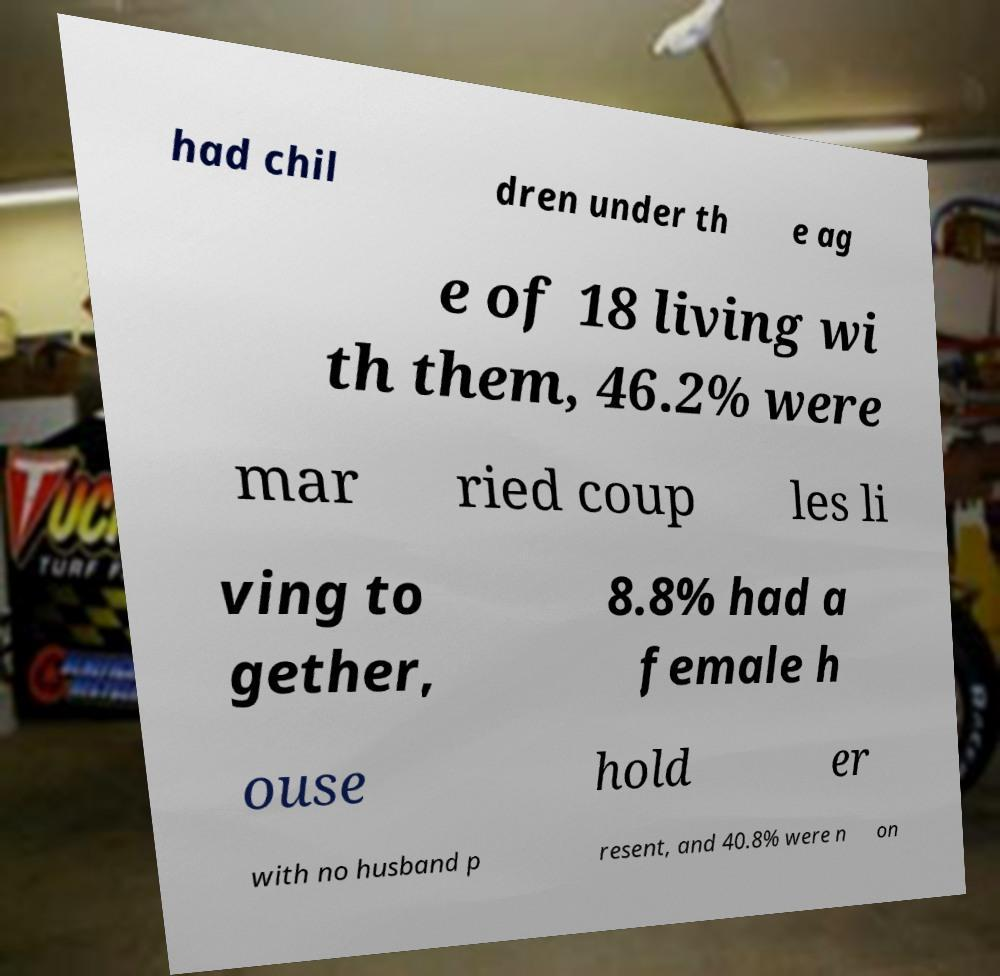For documentation purposes, I need the text within this image transcribed. Could you provide that? had chil dren under th e ag e of 18 living wi th them, 46.2% were mar ried coup les li ving to gether, 8.8% had a female h ouse hold er with no husband p resent, and 40.8% were n on 